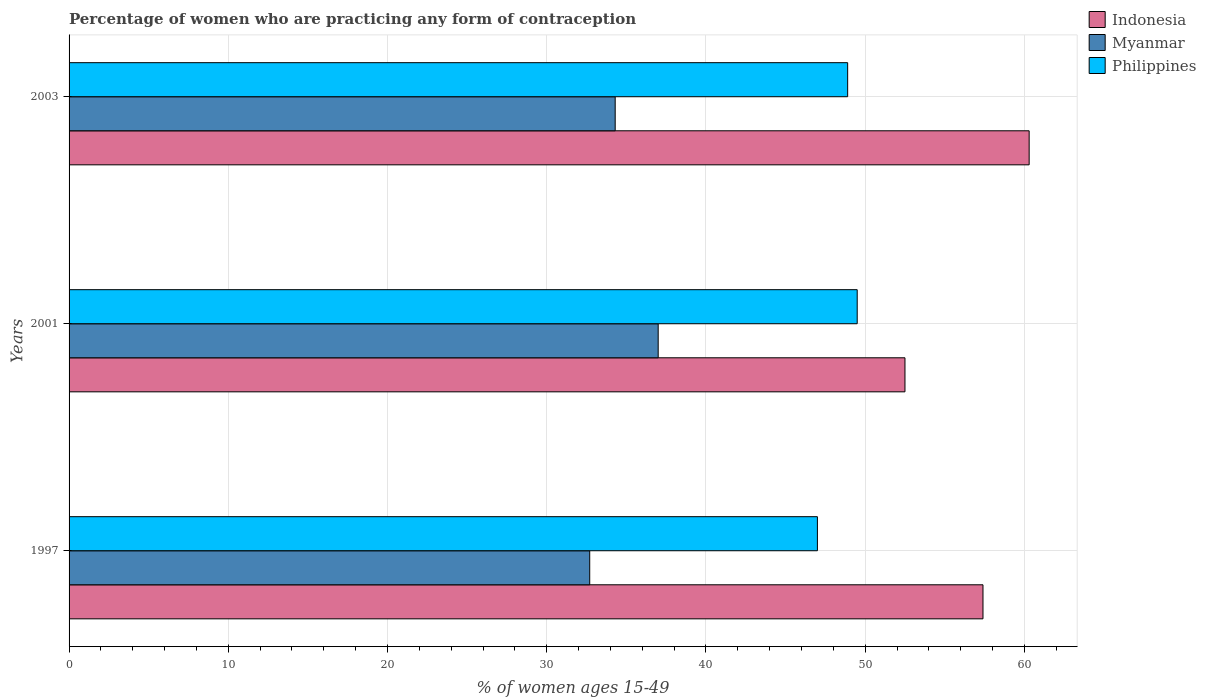How many groups of bars are there?
Your answer should be very brief. 3. Are the number of bars per tick equal to the number of legend labels?
Give a very brief answer. Yes. How many bars are there on the 3rd tick from the top?
Offer a terse response. 3. How many bars are there on the 2nd tick from the bottom?
Provide a short and direct response. 3. What is the percentage of women who are practicing any form of contraception in Myanmar in 2001?
Provide a succinct answer. 37. Across all years, what is the maximum percentage of women who are practicing any form of contraception in Philippines?
Provide a short and direct response. 49.5. Across all years, what is the minimum percentage of women who are practicing any form of contraception in Philippines?
Provide a short and direct response. 47. What is the total percentage of women who are practicing any form of contraception in Myanmar in the graph?
Your answer should be compact. 104. What is the difference between the percentage of women who are practicing any form of contraception in Philippines in 1997 and that in 2003?
Your answer should be compact. -1.9. What is the difference between the percentage of women who are practicing any form of contraception in Indonesia in 1997 and the percentage of women who are practicing any form of contraception in Philippines in 2001?
Provide a succinct answer. 7.9. What is the average percentage of women who are practicing any form of contraception in Philippines per year?
Ensure brevity in your answer.  48.47. In the year 2001, what is the difference between the percentage of women who are practicing any form of contraception in Indonesia and percentage of women who are practicing any form of contraception in Myanmar?
Make the answer very short. 15.5. What is the ratio of the percentage of women who are practicing any form of contraception in Indonesia in 2001 to that in 2003?
Offer a very short reply. 0.87. Is the difference between the percentage of women who are practicing any form of contraception in Indonesia in 1997 and 2003 greater than the difference between the percentage of women who are practicing any form of contraception in Myanmar in 1997 and 2003?
Your answer should be compact. No. What is the difference between the highest and the second highest percentage of women who are practicing any form of contraception in Myanmar?
Your answer should be compact. 2.7. What is the difference between the highest and the lowest percentage of women who are practicing any form of contraception in Philippines?
Your response must be concise. 2.5. In how many years, is the percentage of women who are practicing any form of contraception in Indonesia greater than the average percentage of women who are practicing any form of contraception in Indonesia taken over all years?
Make the answer very short. 2. Is the sum of the percentage of women who are practicing any form of contraception in Indonesia in 1997 and 2001 greater than the maximum percentage of women who are practicing any form of contraception in Philippines across all years?
Offer a very short reply. Yes. What does the 2nd bar from the top in 2001 represents?
Your answer should be very brief. Myanmar. What does the 3rd bar from the bottom in 1997 represents?
Your answer should be compact. Philippines. Are all the bars in the graph horizontal?
Your answer should be compact. Yes. How many years are there in the graph?
Offer a terse response. 3. What is the difference between two consecutive major ticks on the X-axis?
Your answer should be compact. 10. Does the graph contain any zero values?
Provide a short and direct response. No. How many legend labels are there?
Provide a short and direct response. 3. What is the title of the graph?
Your response must be concise. Percentage of women who are practicing any form of contraception. Does "Mauritania" appear as one of the legend labels in the graph?
Your answer should be very brief. No. What is the label or title of the X-axis?
Keep it short and to the point. % of women ages 15-49. What is the % of women ages 15-49 in Indonesia in 1997?
Your answer should be compact. 57.4. What is the % of women ages 15-49 in Myanmar in 1997?
Keep it short and to the point. 32.7. What is the % of women ages 15-49 in Philippines in 1997?
Ensure brevity in your answer.  47. What is the % of women ages 15-49 of Indonesia in 2001?
Give a very brief answer. 52.5. What is the % of women ages 15-49 of Myanmar in 2001?
Offer a terse response. 37. What is the % of women ages 15-49 in Philippines in 2001?
Your answer should be compact. 49.5. What is the % of women ages 15-49 in Indonesia in 2003?
Provide a short and direct response. 60.3. What is the % of women ages 15-49 in Myanmar in 2003?
Your answer should be very brief. 34.3. What is the % of women ages 15-49 of Philippines in 2003?
Ensure brevity in your answer.  48.9. Across all years, what is the maximum % of women ages 15-49 in Indonesia?
Your answer should be very brief. 60.3. Across all years, what is the maximum % of women ages 15-49 of Philippines?
Your response must be concise. 49.5. Across all years, what is the minimum % of women ages 15-49 of Indonesia?
Ensure brevity in your answer.  52.5. Across all years, what is the minimum % of women ages 15-49 of Myanmar?
Your response must be concise. 32.7. What is the total % of women ages 15-49 of Indonesia in the graph?
Provide a succinct answer. 170.2. What is the total % of women ages 15-49 of Myanmar in the graph?
Your answer should be compact. 104. What is the total % of women ages 15-49 of Philippines in the graph?
Provide a short and direct response. 145.4. What is the difference between the % of women ages 15-49 in Indonesia in 1997 and that in 2001?
Provide a succinct answer. 4.9. What is the difference between the % of women ages 15-49 of Myanmar in 1997 and that in 2001?
Offer a very short reply. -4.3. What is the difference between the % of women ages 15-49 in Philippines in 1997 and that in 2001?
Keep it short and to the point. -2.5. What is the difference between the % of women ages 15-49 of Indonesia in 2001 and that in 2003?
Ensure brevity in your answer.  -7.8. What is the difference between the % of women ages 15-49 in Philippines in 2001 and that in 2003?
Your answer should be very brief. 0.6. What is the difference between the % of women ages 15-49 in Indonesia in 1997 and the % of women ages 15-49 in Myanmar in 2001?
Offer a very short reply. 20.4. What is the difference between the % of women ages 15-49 in Indonesia in 1997 and the % of women ages 15-49 in Philippines in 2001?
Your response must be concise. 7.9. What is the difference between the % of women ages 15-49 of Myanmar in 1997 and the % of women ages 15-49 of Philippines in 2001?
Your response must be concise. -16.8. What is the difference between the % of women ages 15-49 in Indonesia in 1997 and the % of women ages 15-49 in Myanmar in 2003?
Provide a short and direct response. 23.1. What is the difference between the % of women ages 15-49 in Myanmar in 1997 and the % of women ages 15-49 in Philippines in 2003?
Offer a very short reply. -16.2. What is the difference between the % of women ages 15-49 in Indonesia in 2001 and the % of women ages 15-49 in Myanmar in 2003?
Your response must be concise. 18.2. What is the difference between the % of women ages 15-49 in Myanmar in 2001 and the % of women ages 15-49 in Philippines in 2003?
Make the answer very short. -11.9. What is the average % of women ages 15-49 in Indonesia per year?
Give a very brief answer. 56.73. What is the average % of women ages 15-49 of Myanmar per year?
Give a very brief answer. 34.67. What is the average % of women ages 15-49 in Philippines per year?
Make the answer very short. 48.47. In the year 1997, what is the difference between the % of women ages 15-49 of Indonesia and % of women ages 15-49 of Myanmar?
Provide a succinct answer. 24.7. In the year 1997, what is the difference between the % of women ages 15-49 in Indonesia and % of women ages 15-49 in Philippines?
Offer a terse response. 10.4. In the year 1997, what is the difference between the % of women ages 15-49 of Myanmar and % of women ages 15-49 of Philippines?
Make the answer very short. -14.3. In the year 2001, what is the difference between the % of women ages 15-49 in Indonesia and % of women ages 15-49 in Philippines?
Give a very brief answer. 3. In the year 2001, what is the difference between the % of women ages 15-49 of Myanmar and % of women ages 15-49 of Philippines?
Provide a short and direct response. -12.5. In the year 2003, what is the difference between the % of women ages 15-49 in Indonesia and % of women ages 15-49 in Philippines?
Offer a terse response. 11.4. In the year 2003, what is the difference between the % of women ages 15-49 in Myanmar and % of women ages 15-49 in Philippines?
Your answer should be very brief. -14.6. What is the ratio of the % of women ages 15-49 of Indonesia in 1997 to that in 2001?
Your response must be concise. 1.09. What is the ratio of the % of women ages 15-49 of Myanmar in 1997 to that in 2001?
Your answer should be very brief. 0.88. What is the ratio of the % of women ages 15-49 in Philippines in 1997 to that in 2001?
Keep it short and to the point. 0.95. What is the ratio of the % of women ages 15-49 in Indonesia in 1997 to that in 2003?
Your answer should be very brief. 0.95. What is the ratio of the % of women ages 15-49 in Myanmar in 1997 to that in 2003?
Offer a very short reply. 0.95. What is the ratio of the % of women ages 15-49 of Philippines in 1997 to that in 2003?
Your response must be concise. 0.96. What is the ratio of the % of women ages 15-49 in Indonesia in 2001 to that in 2003?
Offer a very short reply. 0.87. What is the ratio of the % of women ages 15-49 of Myanmar in 2001 to that in 2003?
Offer a very short reply. 1.08. What is the ratio of the % of women ages 15-49 in Philippines in 2001 to that in 2003?
Offer a terse response. 1.01. What is the difference between the highest and the second highest % of women ages 15-49 of Myanmar?
Offer a very short reply. 2.7. What is the difference between the highest and the second highest % of women ages 15-49 of Philippines?
Your response must be concise. 0.6. What is the difference between the highest and the lowest % of women ages 15-49 in Philippines?
Offer a terse response. 2.5. 